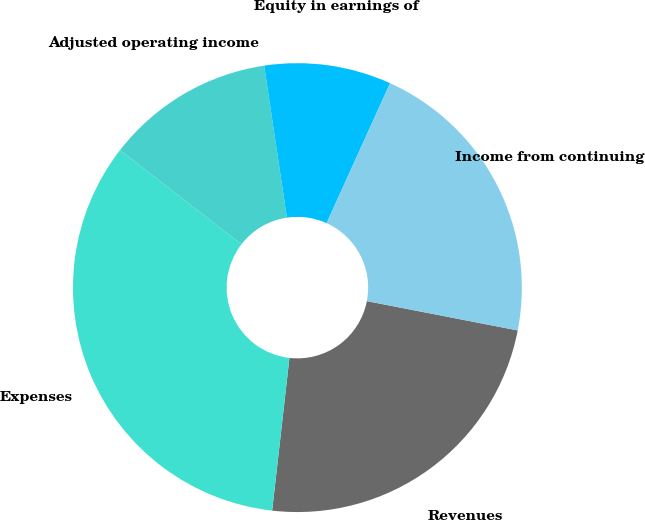Convert chart to OTSL. <chart><loc_0><loc_0><loc_500><loc_500><pie_chart><fcel>Revenues<fcel>Expenses<fcel>Adjusted operating income<fcel>Equity in earnings of<fcel>Income from continuing<nl><fcel>23.74%<fcel>33.7%<fcel>12.14%<fcel>9.14%<fcel>21.28%<nl></chart> 